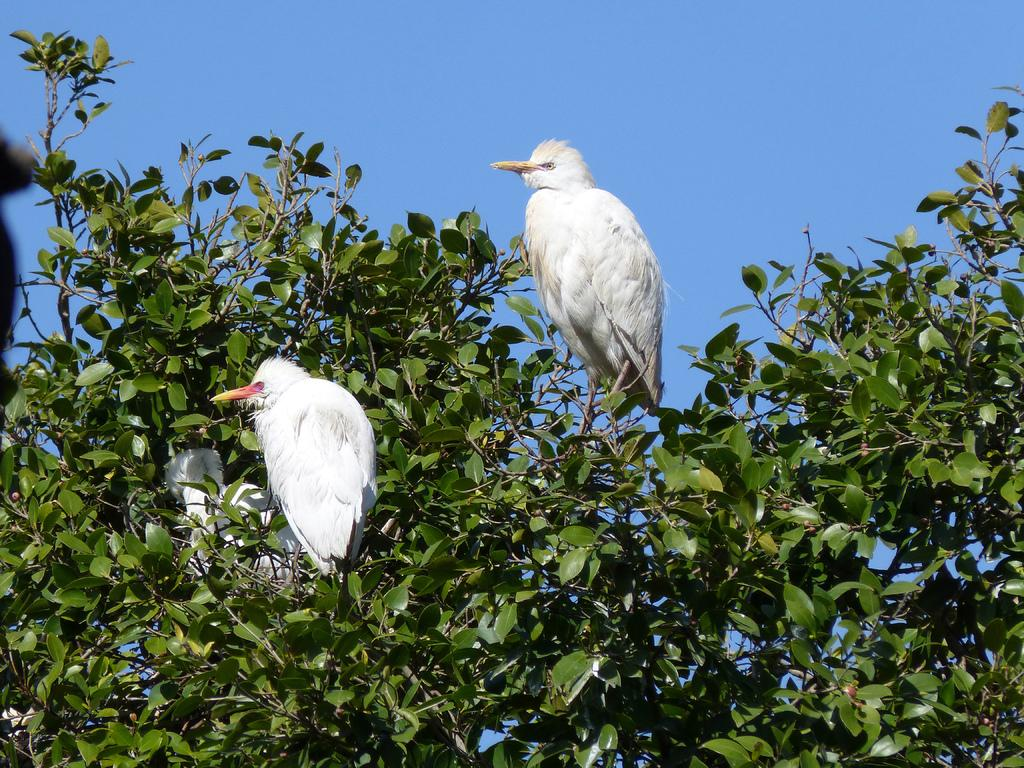What is the main feature in the image? There is a big tree in the image. What can be seen on the tree? There are white color birds on the tree. What is located on the surface in the image? There is an object on the surface in the image. What is visible at the top of the image? The sky is visible at the top of the image. What type of doctor can be seen treating the birds in the image? There is no doctor present in the image, and the birds are not being treated. 